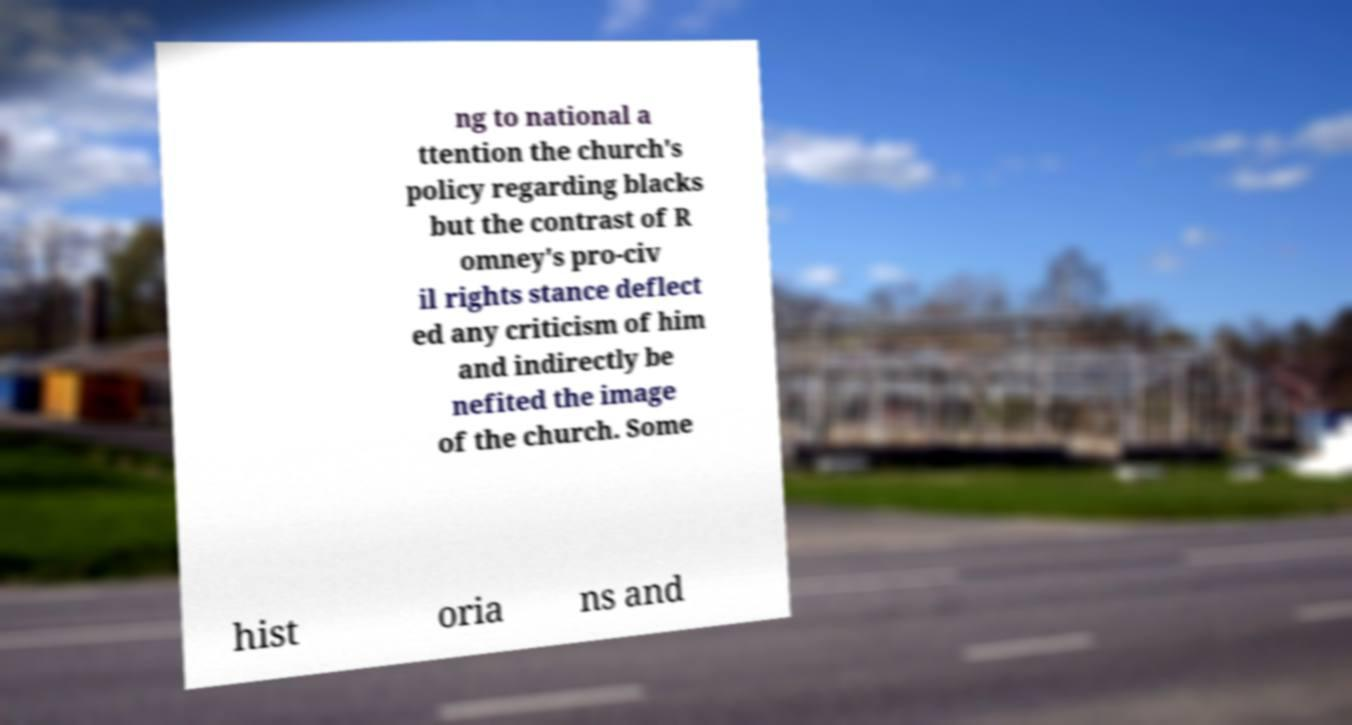Can you accurately transcribe the text from the provided image for me? ng to national a ttention the church's policy regarding blacks but the contrast of R omney's pro-civ il rights stance deflect ed any criticism of him and indirectly be nefited the image of the church. Some hist oria ns and 